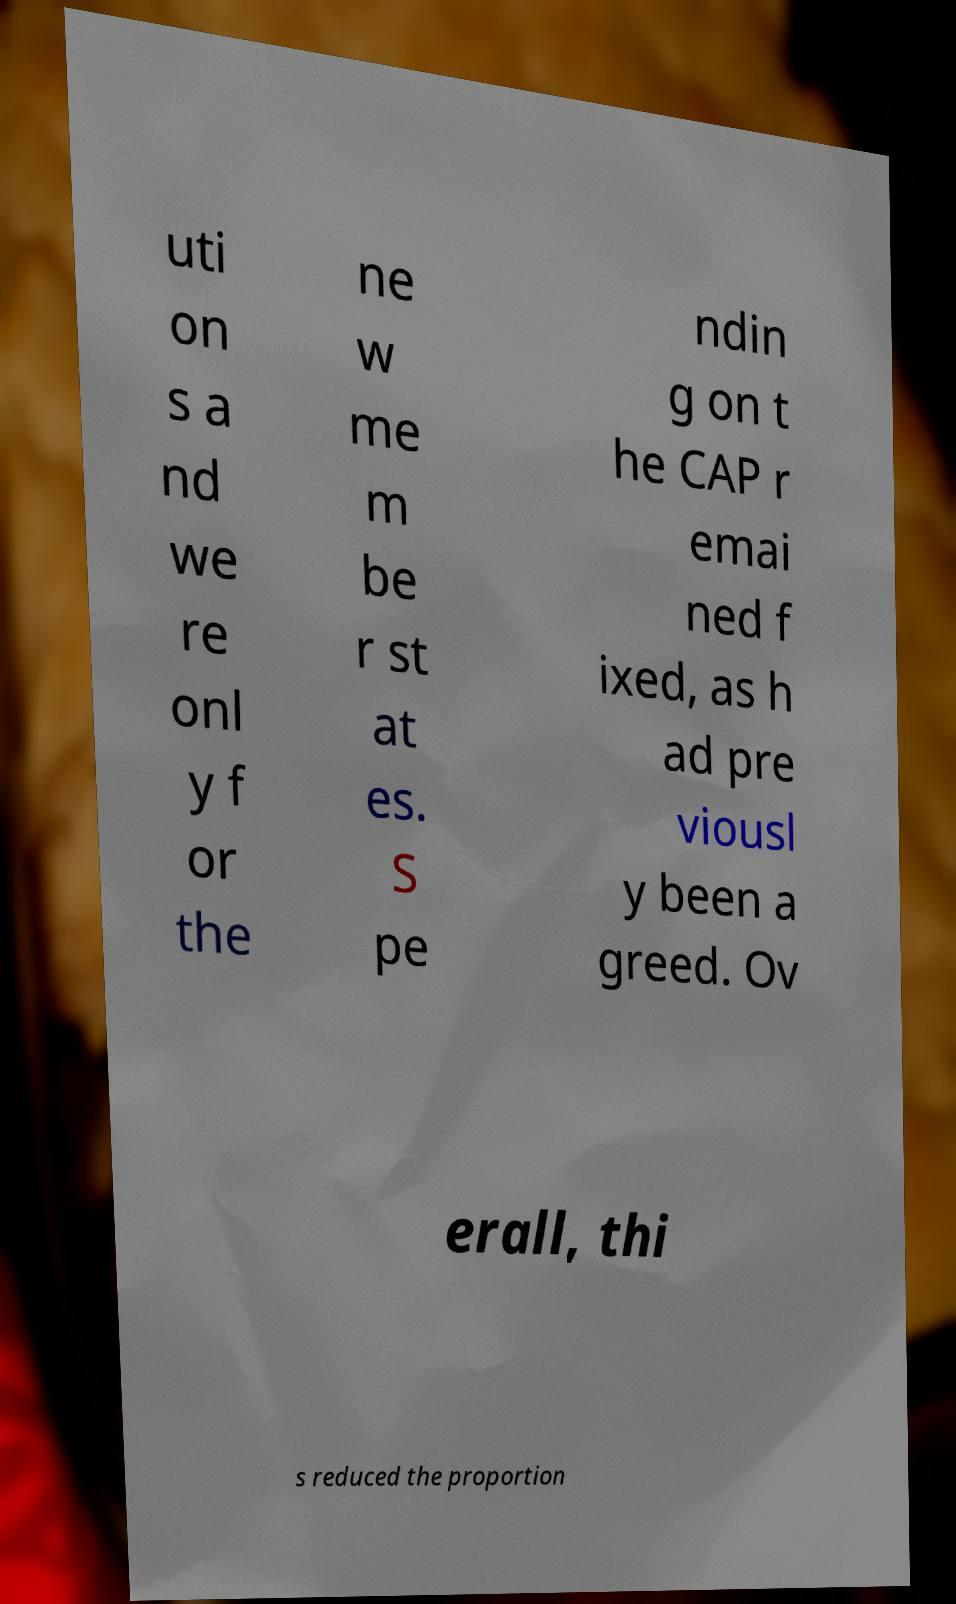Can you read and provide the text displayed in the image?This photo seems to have some interesting text. Can you extract and type it out for me? uti on s a nd we re onl y f or the ne w me m be r st at es. S pe ndin g on t he CAP r emai ned f ixed, as h ad pre viousl y been a greed. Ov erall, thi s reduced the proportion 